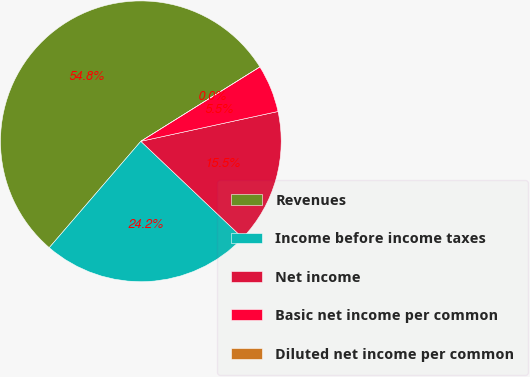Convert chart to OTSL. <chart><loc_0><loc_0><loc_500><loc_500><pie_chart><fcel>Revenues<fcel>Income before income taxes<fcel>Net income<fcel>Basic net income per common<fcel>Diluted net income per common<nl><fcel>54.8%<fcel>24.23%<fcel>15.49%<fcel>5.48%<fcel>0.0%<nl></chart> 